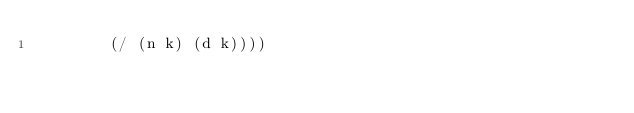<code> <loc_0><loc_0><loc_500><loc_500><_Scheme_>        (/ (n k) (d k))))
</code> 